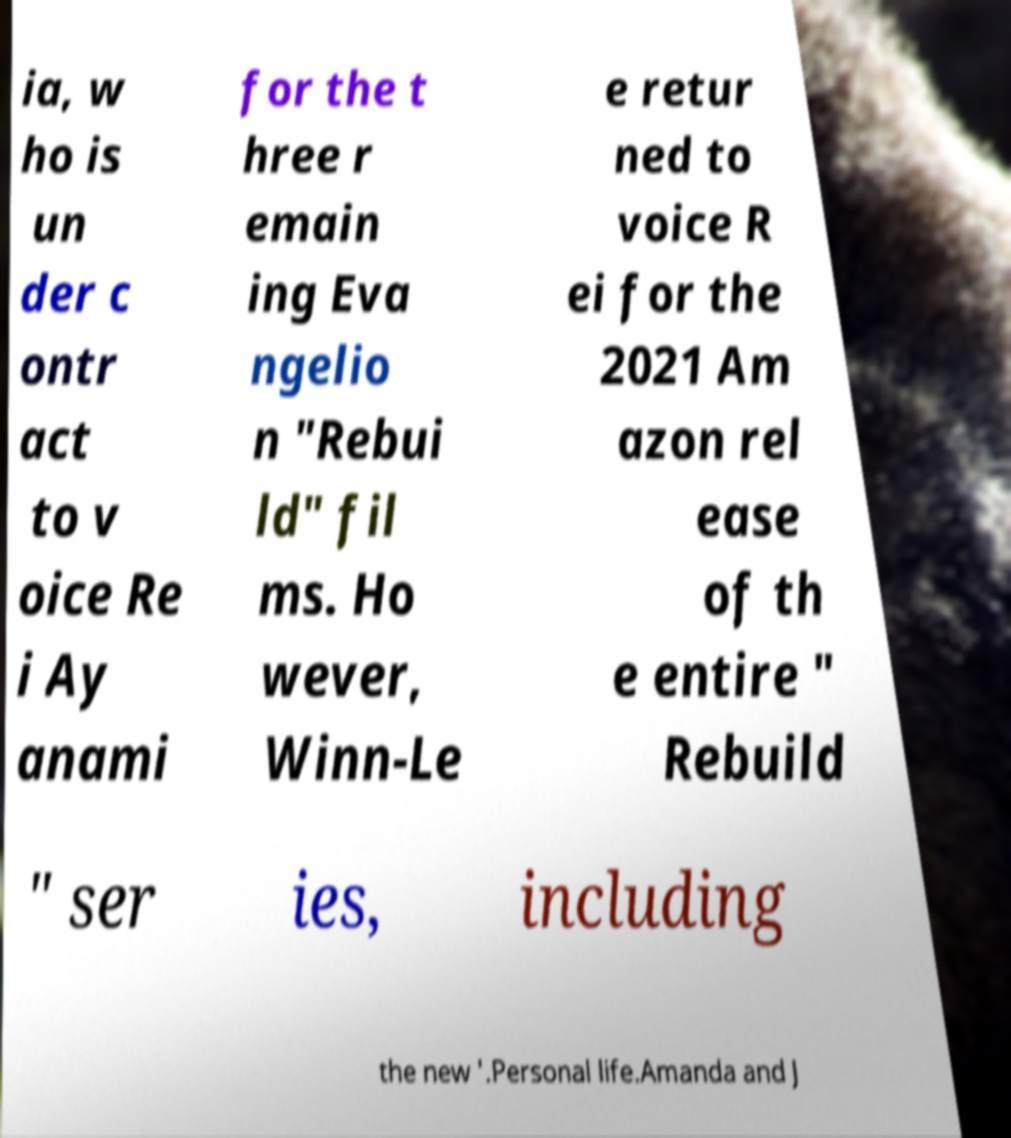What messages or text are displayed in this image? I need them in a readable, typed format. ia, w ho is un der c ontr act to v oice Re i Ay anami for the t hree r emain ing Eva ngelio n "Rebui ld" fil ms. Ho wever, Winn-Le e retur ned to voice R ei for the 2021 Am azon rel ease of th e entire " Rebuild " ser ies, including the new '.Personal life.Amanda and J 